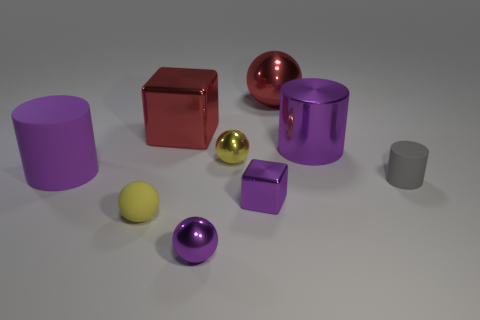How many objects in this scene have a reflective surface? In the scene, there are 6 objects with reflective surfaces, including spheres, cubes, and cylinders. 